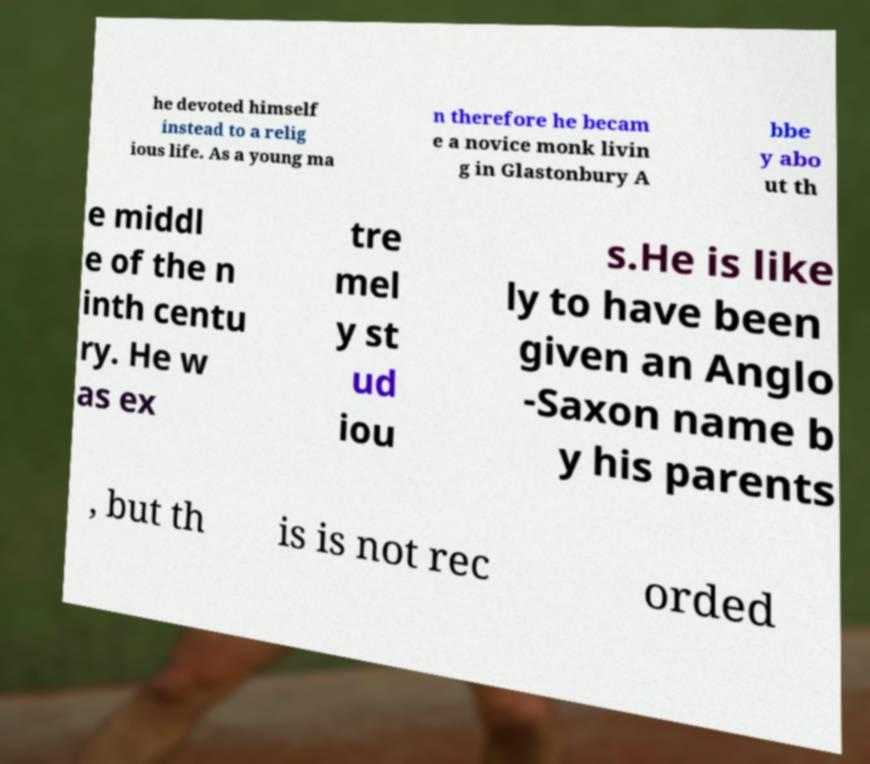Could you extract and type out the text from this image? he devoted himself instead to a relig ious life. As a young ma n therefore he becam e a novice monk livin g in Glastonbury A bbe y abo ut th e middl e of the n inth centu ry. He w as ex tre mel y st ud iou s.He is like ly to have been given an Anglo -Saxon name b y his parents , but th is is not rec orded 